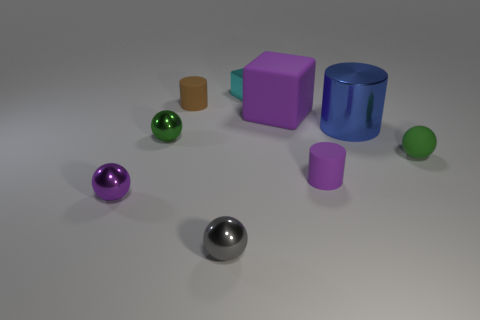Does the tiny brown thing have the same shape as the cyan thing that is on the left side of the tiny purple rubber thing?
Ensure brevity in your answer.  No. How many other objects are the same material as the purple ball?
Your response must be concise. 4. Are there any metal balls in front of the purple sphere?
Give a very brief answer. Yes. Is the size of the green rubber ball the same as the purple thing that is left of the cyan metallic object?
Provide a short and direct response. Yes. What is the color of the object in front of the purple object on the left side of the brown rubber cylinder?
Offer a terse response. Gray. Is the size of the purple block the same as the gray ball?
Give a very brief answer. No. There is a shiny sphere that is both left of the small brown cylinder and in front of the purple cylinder; what is its color?
Your answer should be compact. Purple. What is the size of the brown rubber cylinder?
Your answer should be very brief. Small. Do the thing that is on the right side of the blue shiny object and the metal block have the same color?
Your answer should be compact. No. Is the number of brown rubber things that are behind the green shiny object greater than the number of green rubber spheres in front of the purple sphere?
Your answer should be very brief. Yes. 